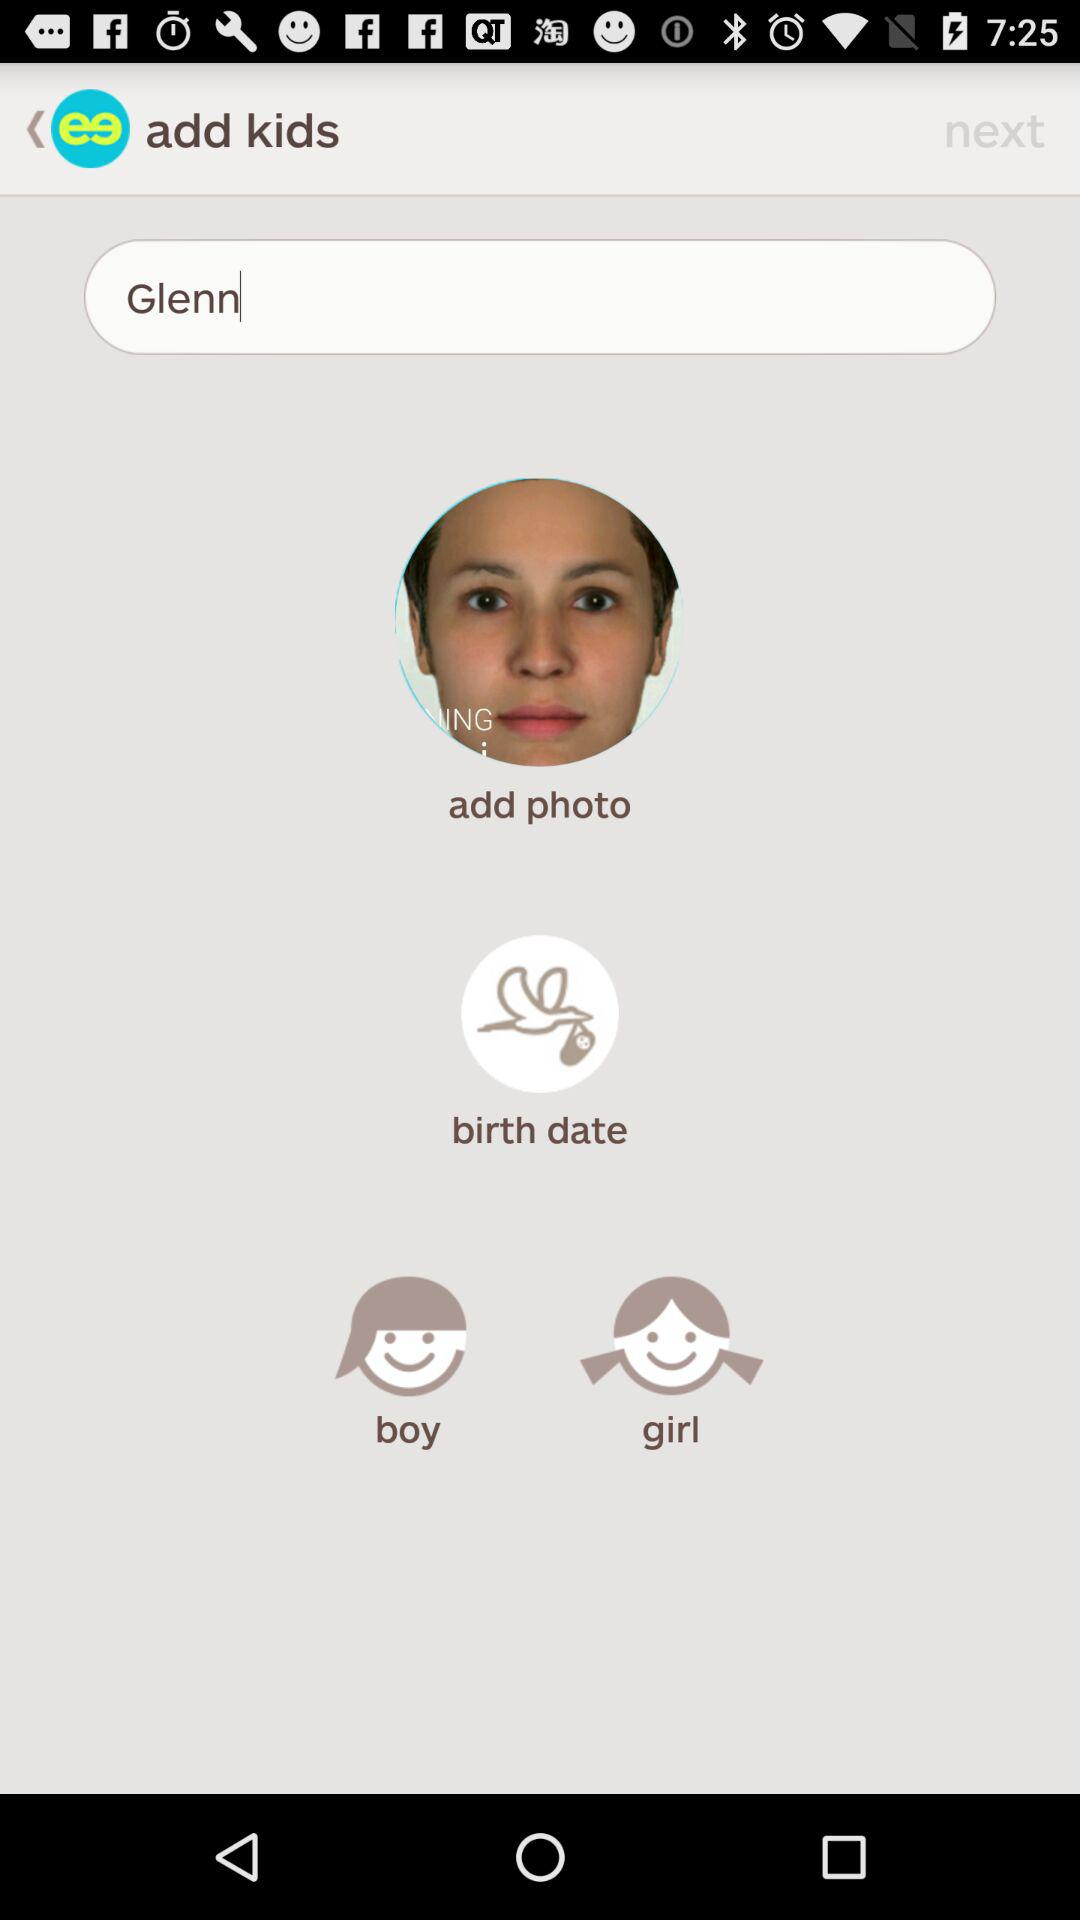Is Glenn a boy or girl?
When the provided information is insufficient, respond with <no answer>. <no answer> 